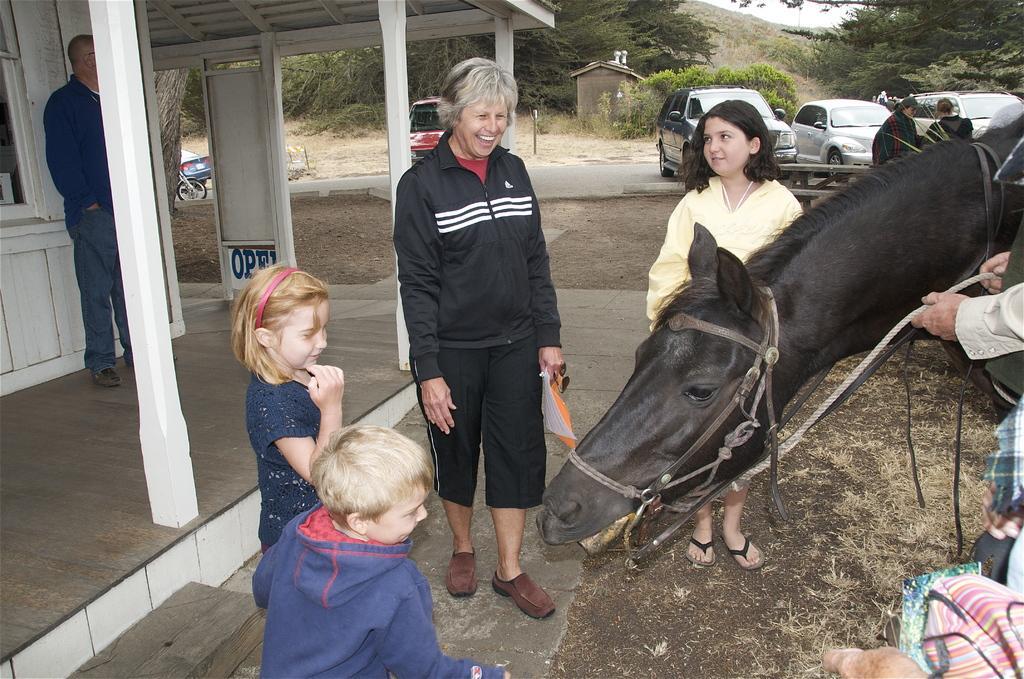Please provide a concise description of this image. in the image there is a woman stood and smiling,beside her there are some kids stood and in front there is a horse and in the background there are cars. 